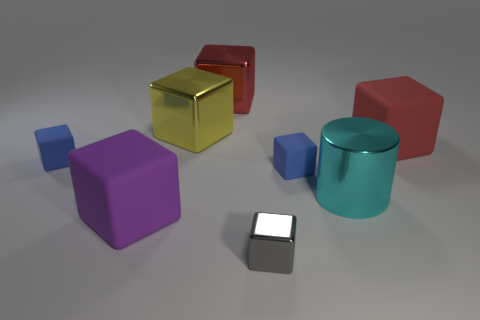Is there any other thing that is the same color as the cylinder?
Provide a short and direct response. No. There is a big red object to the left of the large red object on the right side of the gray shiny object; how many small gray things are on the left side of it?
Your answer should be compact. 0. What number of blue things are either big objects or blocks?
Offer a very short reply. 2. Is the size of the red shiny cube the same as the blue matte cube that is right of the large yellow cube?
Provide a succinct answer. No. What material is the large yellow thing that is the same shape as the red metal object?
Offer a terse response. Metal. What number of other things are there of the same size as the red shiny block?
Make the answer very short. 4. There is a cyan metal thing that is behind the large block that is in front of the tiny blue matte object on the left side of the large purple matte thing; what shape is it?
Your answer should be compact. Cylinder. What is the shape of the tiny thing that is on the right side of the purple thing and behind the big cylinder?
Offer a terse response. Cube. How many things are tiny green balls or matte blocks in front of the cyan thing?
Make the answer very short. 1. Is the material of the gray object the same as the cyan cylinder?
Your response must be concise. Yes. 